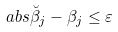Convert formula to latex. <formula><loc_0><loc_0><loc_500><loc_500>\ a b s { \breve { \beta } _ { j } - \beta _ { j } } \leq \varepsilon</formula> 